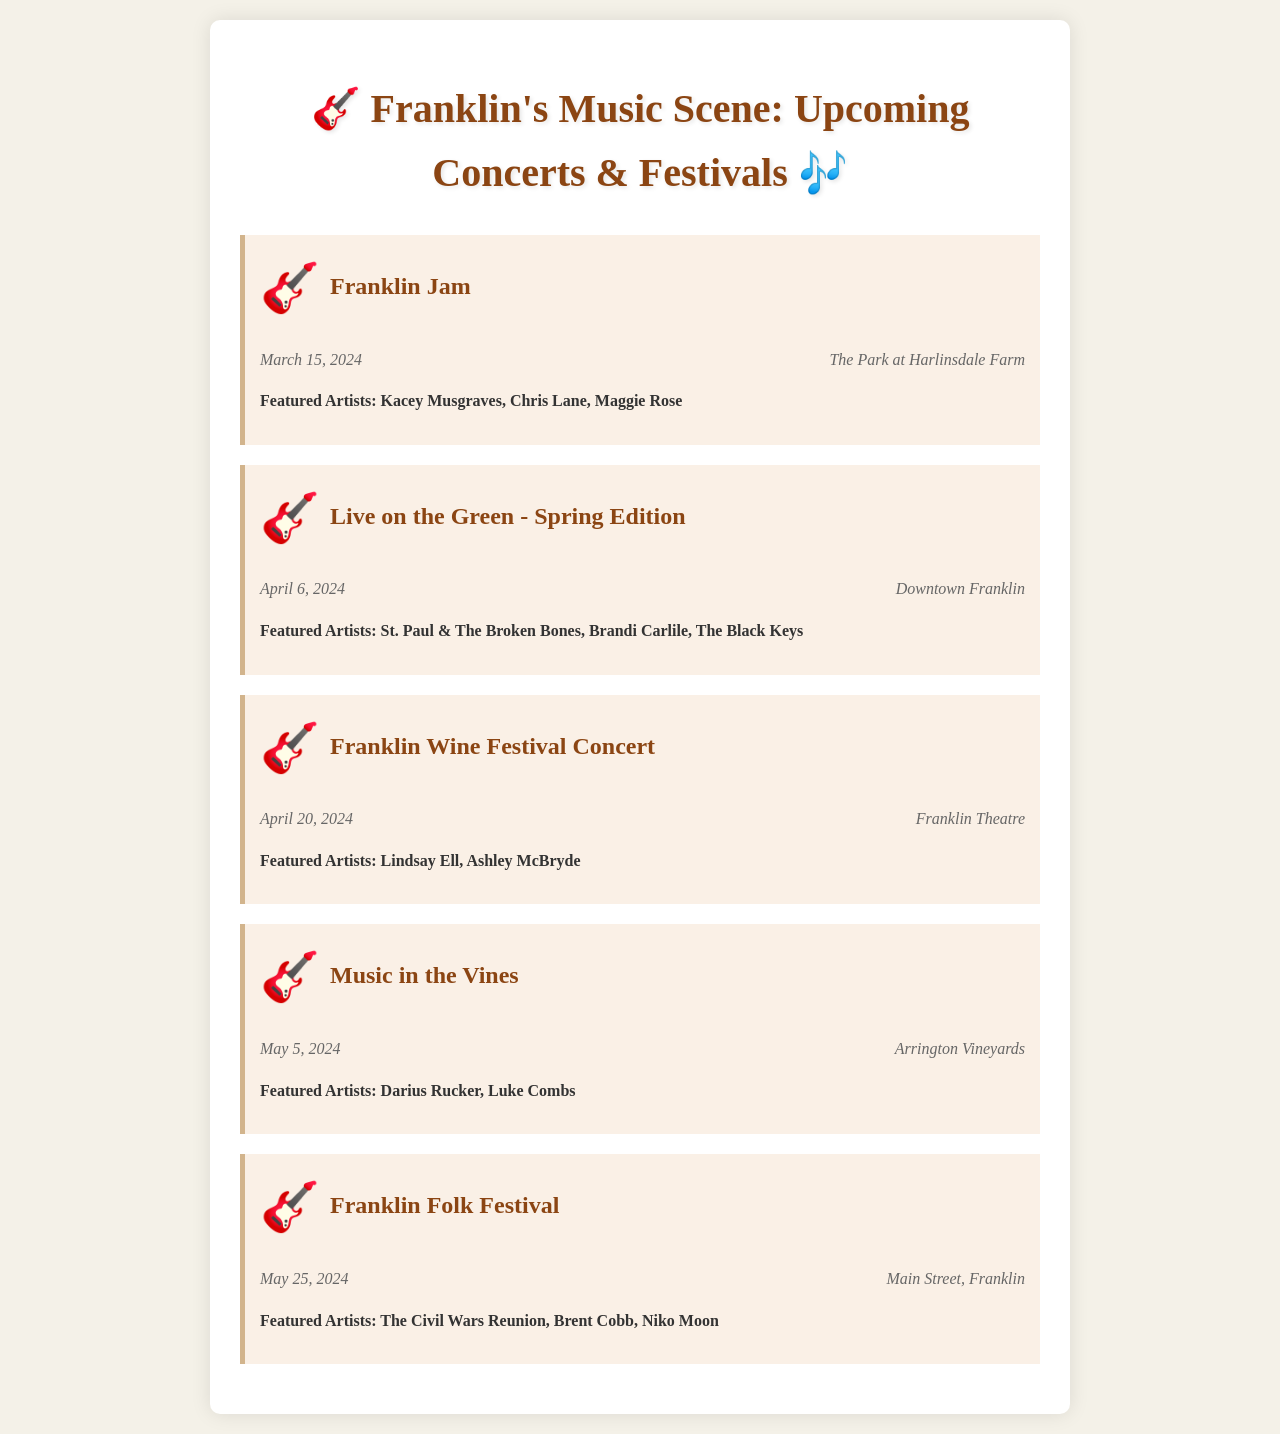What is the date of the Franklin Jam? The document states that the Franklin Jam is scheduled for March 15, 2024.
Answer: March 15, 2024 Where is the Live on the Green event taking place? The venue for the Live on the Green event is Downtown Franklin, as indicated in the document.
Answer: Downtown Franklin Who are the featured artists for the Franklin Wine Festival Concert? According to the document, the featured artists are Lindsay Ell and Ashley McBryde.
Answer: Lindsay Ell, Ashley McBryde What is the venue for the Music in the Vines event? The document lists Arrington Vineyards as the venue for the Music in the Vines event.
Answer: Arrington Vineyards How many featured artists are listed for the Franklin Folk Festival? The document mentions three featured artists for the Franklin Folk Festival.
Answer: Three Which event occurs in May? The document shows two events occurring in May, which are Music in the Vines and Franklin Folk Festival.
Answer: Music in the Vines, Franklin Folk Festival What type of event is highlighted on April 6, 2024? The event on April 6, 2024, is a concert named Live on the Green - Spring Edition.
Answer: Concert Which artist is performing at the Franklin Jam? The document lists Kacey Musgraves as one of the featured artists at the Franklin Jam.
Answer: Kacey Musgraves When is the Franklin Folk Festival scheduled? The date for the Franklin Folk Festival is mentioned as May 25, 2024, in the document.
Answer: May 25, 2024 